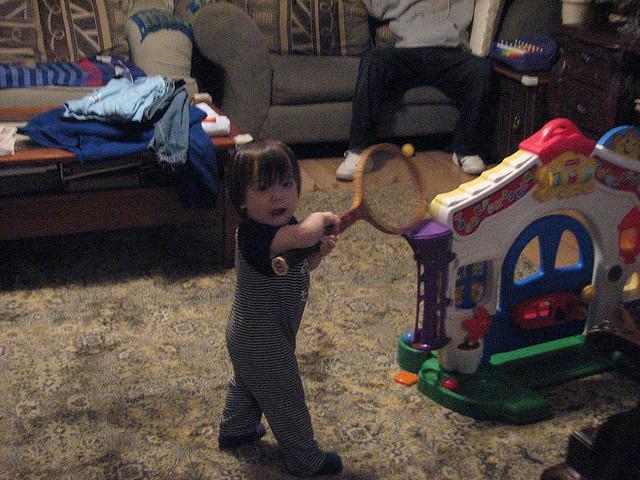How many couches are there?
Give a very brief answer. 2. How many people are in the photo?
Give a very brief answer. 2. 